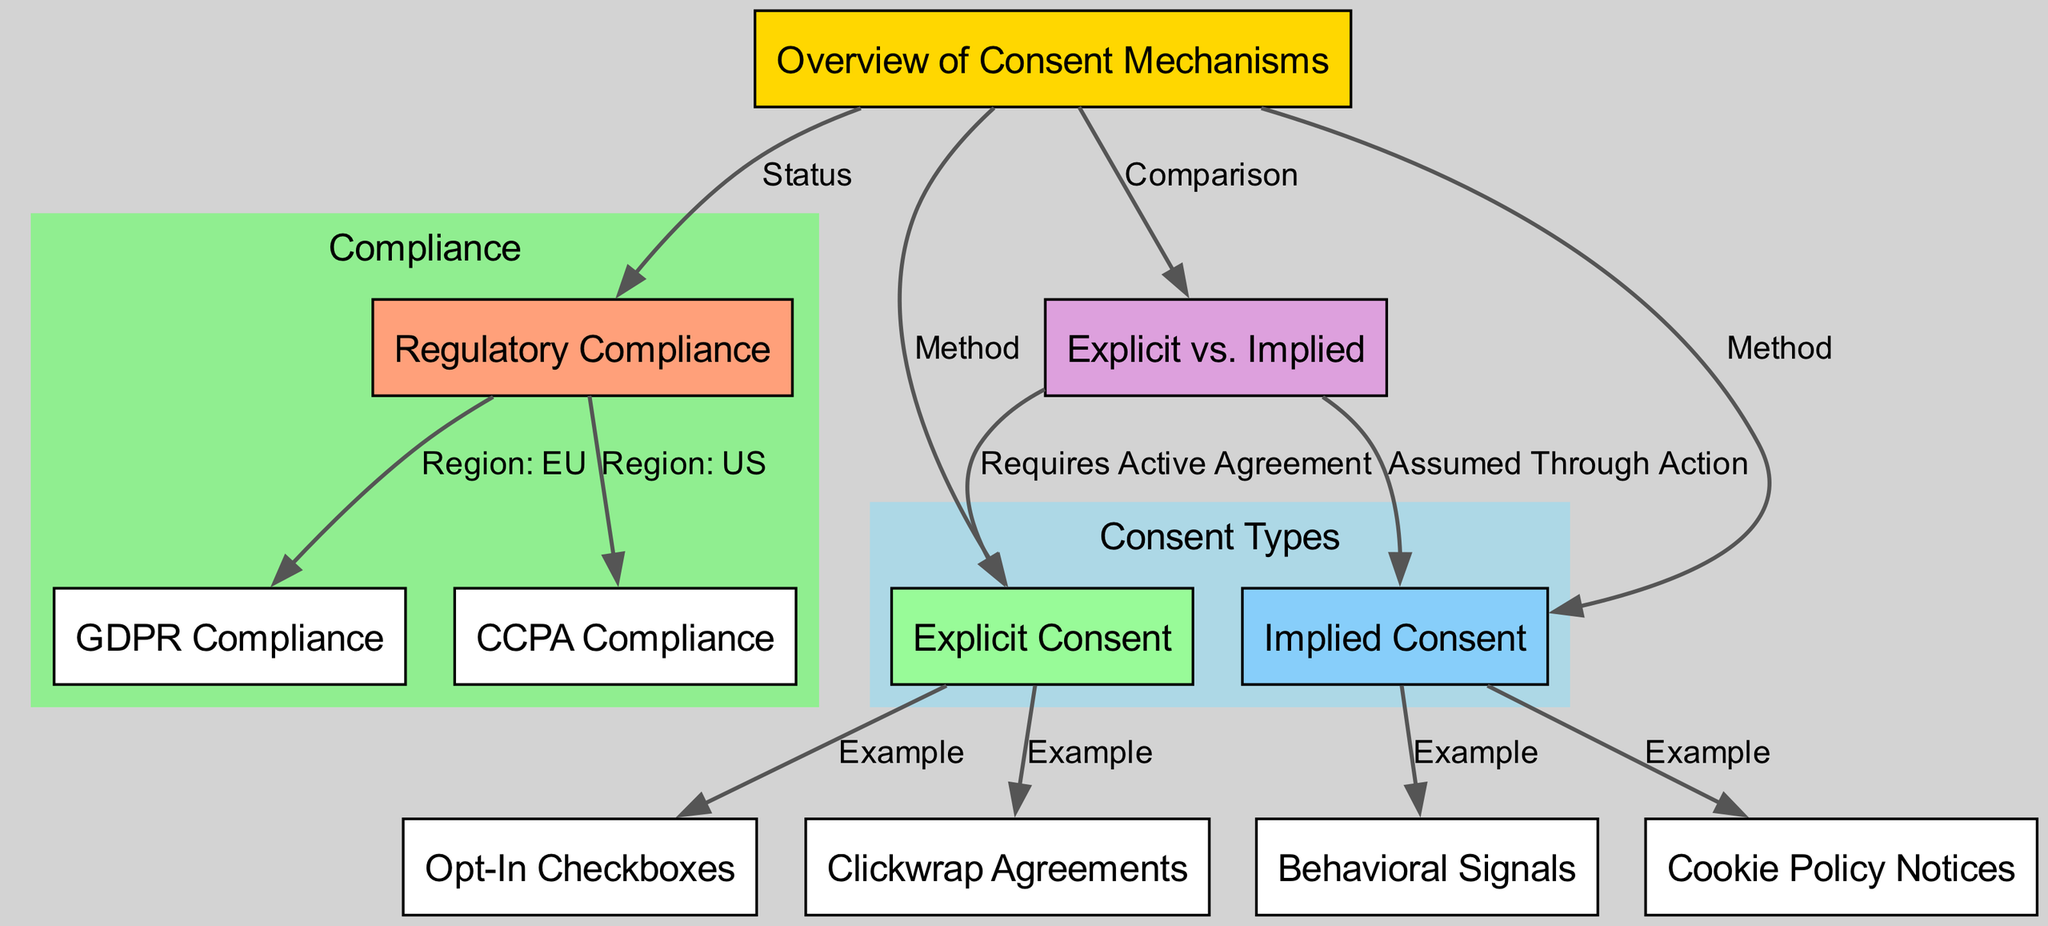What are the two main types of consent mechanisms? The diagram labels two primary consent types: "Explicit Consent" and "Implied Consent", which are directly connected to the "Overview of Consent Mechanisms" node.
Answer: Explicit Consent, Implied Consent How many examples are provided for Explicit Consent? The diagram shows two examples branching from the "Explicit Consent" node: "Opt-In Checkboxes" and "Clickwrap Agreements", indicating there are two examples.
Answer: 2 Which consent type requires an active agreement from the user? The node "Explicit vs. Implied" points to "Explicit Consent" as requiring an active agreement, highlighting the difference between the types regarding user involvement.
Answer: Explicit Consent What is associated with the Regulatory Compliance node in the EU region? According to the diagram, the "Regulatory Compliance" node points to "GDPR Compliance", indicating what compliance is responsible within that region.
Answer: GDPR Compliance What does Implied Consent assume about user actions? The diagram illustrates that for "Implied Consent", the action taken by the user is interpreted as consent, making it an assumption about user behavior.
Answer: Assumed Through Action What method is listed for obtaining Implied Consent? The "Implied Consent" node connects to two examples, one of which is "Behavioral Signals", indicating how Implied Consent might be obtained through user actions rather than explicit approval.
Answer: Behavioral Signals What is the compliance status depicted in the diagram? The diagram links the "Overview of Consent Mechanisms" to "Regulatory Compliance", which encompasses compliance requirements, specifically addressing different regions like the EU and US.
Answer: Regulatory Compliance How does the diagram categorize Consent Types? The diagram demarcates the "Consent Types" section by visually grouping the "Explicit Consent" and "Implied Consent" nodes within a subgraph labeled as 'Consent Types'.
Answer: Consent Types 